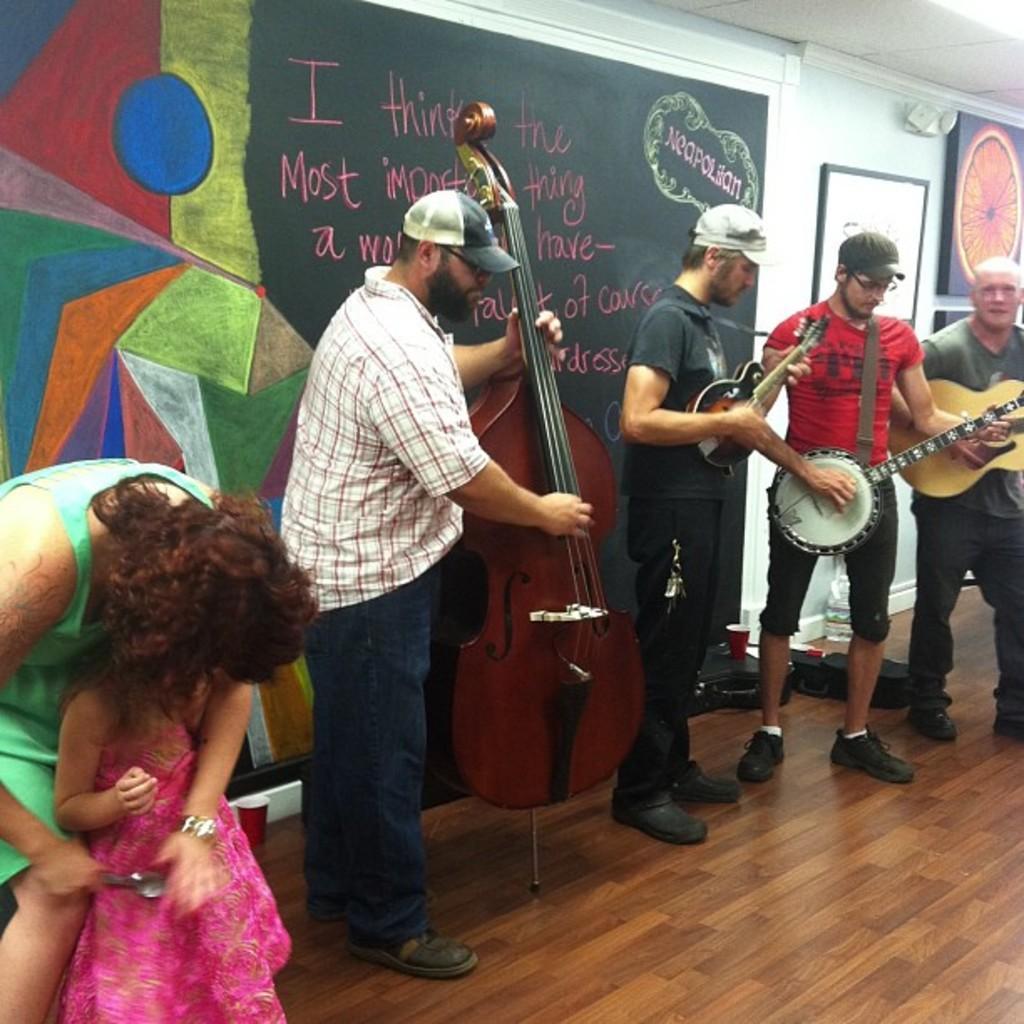Please provide a concise description of this image. In this image there are people playing musical instruments. Beside them there are two other people standing on the floor. Behind them there is a painting and some text on the wall. On the right side of the image there are photo frames attached to the wall. 